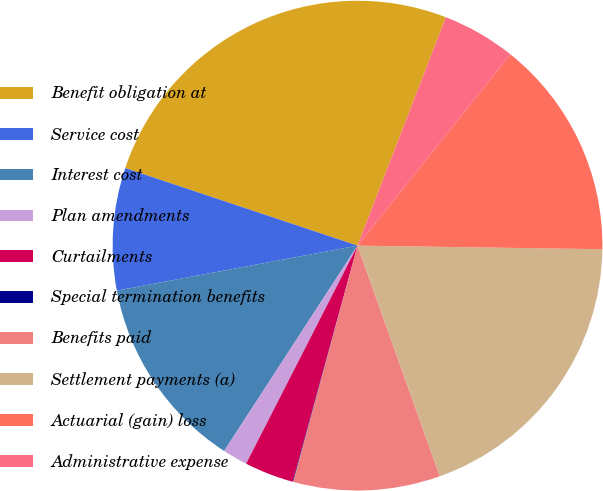Convert chart to OTSL. <chart><loc_0><loc_0><loc_500><loc_500><pie_chart><fcel>Benefit obligation at<fcel>Service cost<fcel>Interest cost<fcel>Plan amendments<fcel>Curtailments<fcel>Special termination benefits<fcel>Benefits paid<fcel>Settlement payments (a)<fcel>Actuarial (gain) loss<fcel>Administrative expense<nl><fcel>25.74%<fcel>8.07%<fcel>12.89%<fcel>1.65%<fcel>3.25%<fcel>0.04%<fcel>9.68%<fcel>19.31%<fcel>14.5%<fcel>4.86%<nl></chart> 